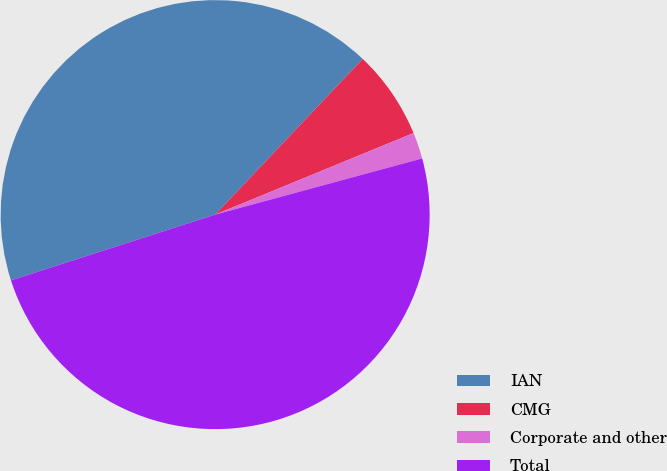Convert chart. <chart><loc_0><loc_0><loc_500><loc_500><pie_chart><fcel>IAN<fcel>CMG<fcel>Corporate and other<fcel>Total<nl><fcel>42.03%<fcel>6.72%<fcel>1.99%<fcel>49.26%<nl></chart> 